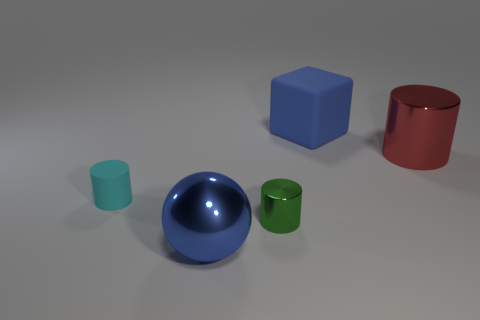Subtract all tiny cyan rubber cylinders. How many cylinders are left? 2 Subtract all brown cylinders. Subtract all cyan balls. How many cylinders are left? 3 Add 4 tiny green metal objects. How many objects exist? 9 Subtract all spheres. How many objects are left? 4 Add 4 big red metal things. How many big red metal things are left? 5 Add 3 red matte things. How many red matte things exist? 3 Subtract 1 red cylinders. How many objects are left? 4 Subtract all objects. Subtract all tiny yellow matte cylinders. How many objects are left? 0 